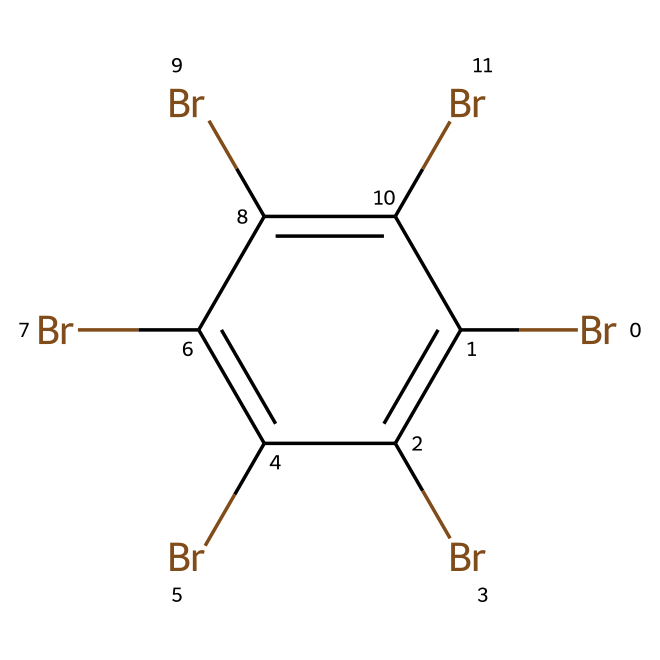What is the total number of bromine atoms in this compound? The SMILES representation indicates the presence of six "Br" symbols, which represent bromine atoms. Therefore, counting these reveals that the chemical contains a total of six bromine atoms.
Answer: six What is the chemical structure's aromatic nature? The chemical contains a cyclic structure (indicated by "c") with alternating bonds, typical of aromatic compounds. The presence of six carbon atoms in a ring with substituents further confirms the aromatic nature.
Answer: aromatic How many carbon atoms are present in this compound? The SMILES notation includes "c" six times, which indicates the presence of six carbon atoms in the structure. Counting all occurrences of "c" confirms that there are exactly six carbon atoms.
Answer: six What is the primary halogen present in this compound? The only halogen indicated in the SMILES is bromine, as shown by the repeated "Br" symbols. Thus, bromine is the primary halogen in this flame retardant compound.
Answer: bromine Does this compound contain hydrogen atoms? The absence of "H" in the SMILES implies that there are no hydrogen atoms present. In fully halogenated aromatic compounds, typically, hydrogen is replaced by halogen atoms, leading to no remaining hydrogen.
Answer: no What type of reactions might this compound undergo due to its halogenation? The presence of multiple bromine atoms suggests that the compound may undergo reactions typical for halogenated aromatics, such as electrophilic substitution reactions. This is due to the stability of the aromatic system combined with the reactivity of the bromine substituents.
Answer: electrophilic substitution 